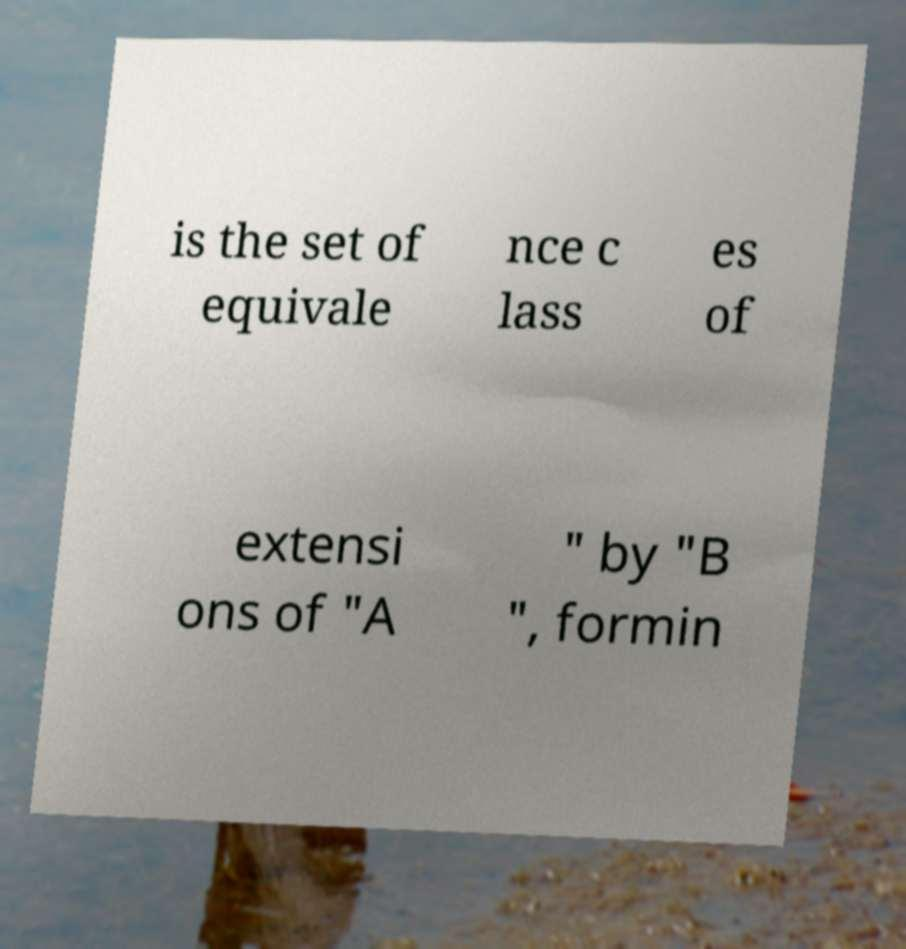Could you assist in decoding the text presented in this image and type it out clearly? is the set of equivale nce c lass es of extensi ons of "A " by "B ", formin 